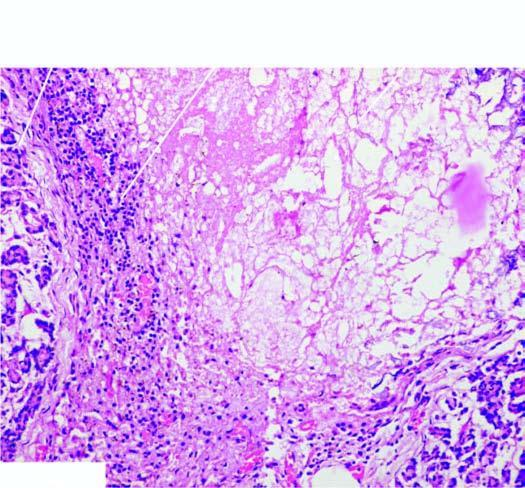what is there of acinar tissue?
Answer the question using a single word or phrase. Destruction 